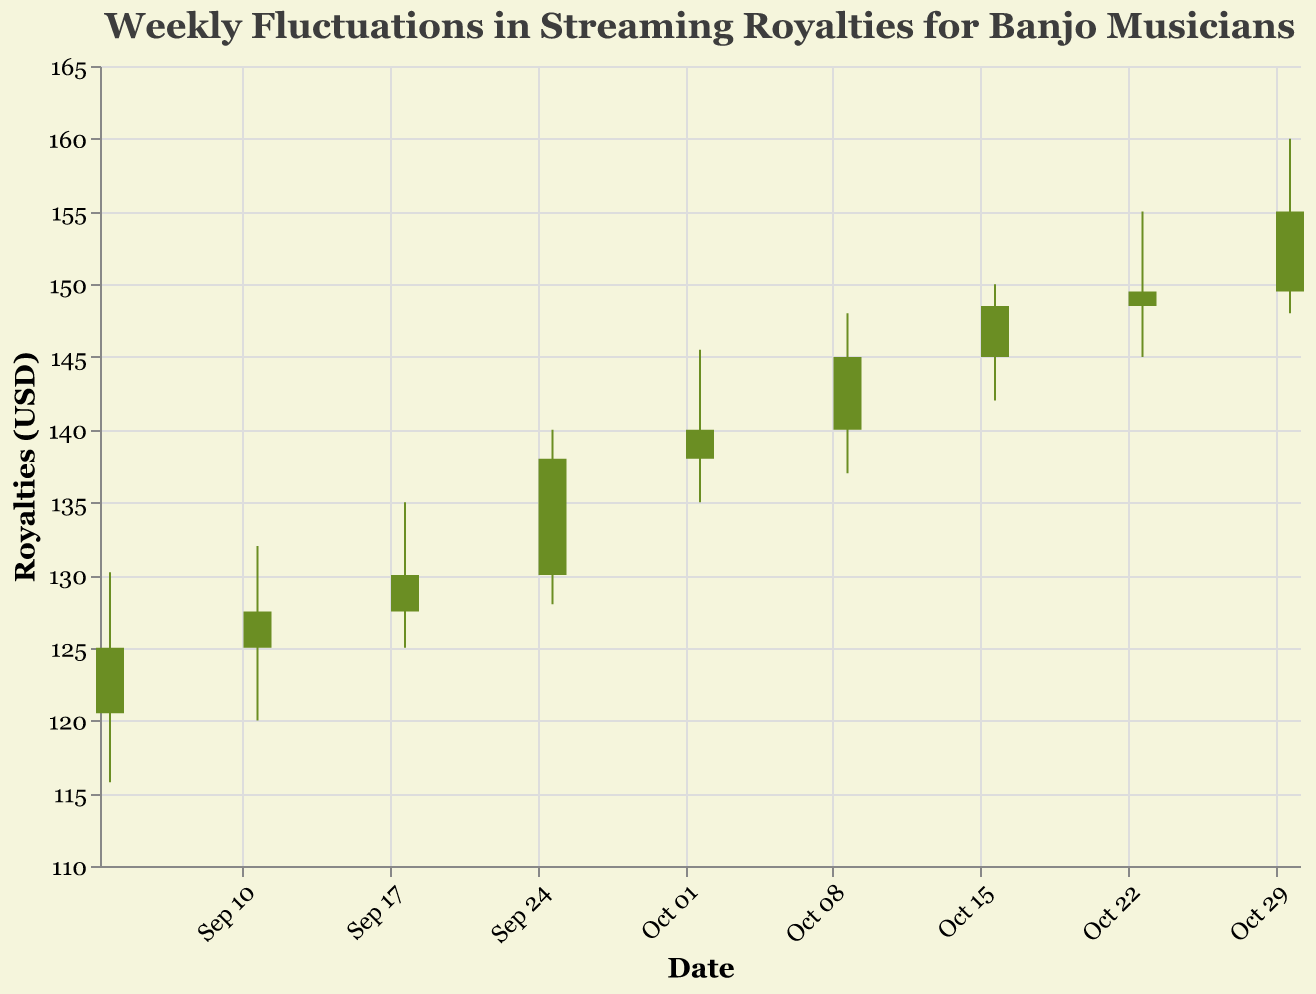What is the title of the chart? The title of the chart is found at the top and describes the general content of the chart.
Answer: Weekly Fluctuations in Streaming Royalties for Banjo Musicians How many weeks of data are displayed in the chart? The chart shows the weekly data points for each week from September 4, 2023, to October 30, 2023. We can count the number of dates listed on the x-axis.
Answer: 9 weeks On which date did the royalties have the highest 'High' value? By inspecting the 'High' values on all candlesticks, the highest point reached is on the week of October 30, 2023, at 160.00 USD.
Answer: October 30, 2023 What was the 'Open' value for the week starting on September 18, 2023? By examining the candlestick for the week of September 18, 2023, the 'Open' value is located at the top edge of the lower rectangle.
Answer: 127.50 USD Which week showed the greatest increase in royalties from 'Open' to 'Close'? Calculate the differences between 'Open' and 'Close' for each week and find the maximum. The week of September 25, 2023, showed an increase of 8.00 USD (from 130.00 to 138.00).
Answer: September 25, 2023 Compare the 'Close' values for the weeks of October 9, 2023, and October 16, 2023. Which one is higher? Look at the 'Close' values at the top of the upper rectangles. October 16 has a 'Close' value of 148.50 USD, and October 9 has a 'Close' value of 145.00 USD.
Answer: October 16, 2023 What is the average 'Close' value for all the weeks? Sum all 'Close' values and divide by the number of weeks: (125.00 + 127.50 + 130.00 + 138.00 + 140.00 + 145.00 + 148.50 + 149.50 + 155.00)/9.
Answer: 139.50 USD On which week did the 'Low' value fall below 120.00 USD? Check the 'Low' values of all candlesticks to find when it dipped below 120.00 USD. This occurred on the week of September 4, 2023, with a 'Low' of 115.75 USD.
Answer: September 4, 2023 What pattern can be observed when comparing 'Open' values over consecutive weeks? Examine the 'Open' value for each week. The pattern shows a generally increasing trend week by week.
Answer: Increasing trend 